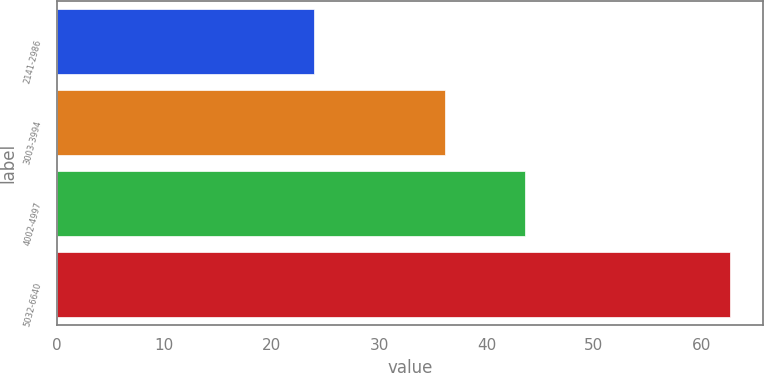Convert chart to OTSL. <chart><loc_0><loc_0><loc_500><loc_500><bar_chart><fcel>2141-2986<fcel>3003-3994<fcel>4002-4997<fcel>5032-6640<nl><fcel>23.99<fcel>36.12<fcel>43.56<fcel>62.62<nl></chart> 